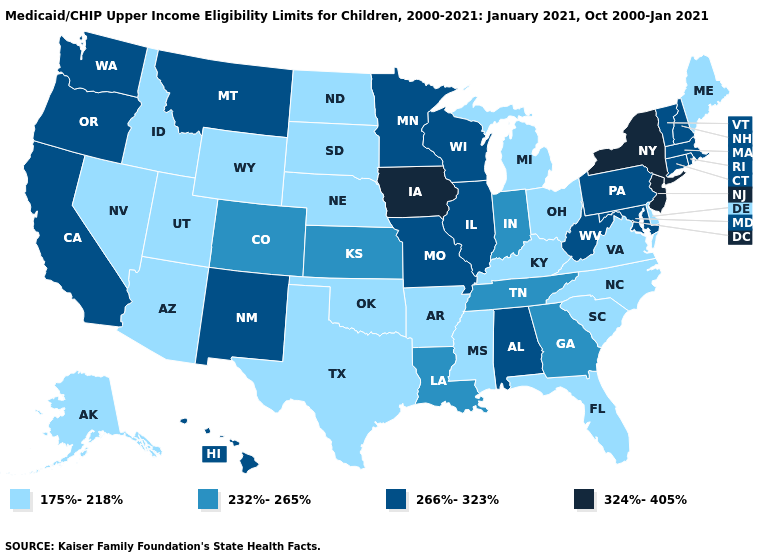Does the first symbol in the legend represent the smallest category?
Concise answer only. Yes. Among the states that border Ohio , which have the lowest value?
Keep it brief. Kentucky, Michigan. What is the value of South Carolina?
Answer briefly. 175%-218%. What is the value of Hawaii?
Write a very short answer. 266%-323%. What is the value of Minnesota?
Keep it brief. 266%-323%. Name the states that have a value in the range 232%-265%?
Quick response, please. Colorado, Georgia, Indiana, Kansas, Louisiana, Tennessee. Among the states that border Maryland , which have the lowest value?
Be succinct. Delaware, Virginia. Name the states that have a value in the range 232%-265%?
Be succinct. Colorado, Georgia, Indiana, Kansas, Louisiana, Tennessee. What is the value of West Virginia?
Write a very short answer. 266%-323%. What is the value of West Virginia?
Write a very short answer. 266%-323%. Which states have the lowest value in the USA?
Short answer required. Alaska, Arizona, Arkansas, Delaware, Florida, Idaho, Kentucky, Maine, Michigan, Mississippi, Nebraska, Nevada, North Carolina, North Dakota, Ohio, Oklahoma, South Carolina, South Dakota, Texas, Utah, Virginia, Wyoming. What is the value of Illinois?
Give a very brief answer. 266%-323%. Which states hav the highest value in the Northeast?
Give a very brief answer. New Jersey, New York. Which states hav the highest value in the West?
Quick response, please. California, Hawaii, Montana, New Mexico, Oregon, Washington. Among the states that border Kentucky , does West Virginia have the highest value?
Answer briefly. Yes. 